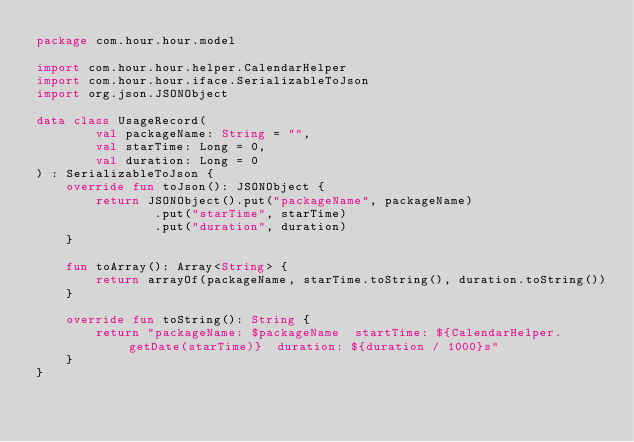Convert code to text. <code><loc_0><loc_0><loc_500><loc_500><_Kotlin_>package com.hour.hour.model

import com.hour.hour.helper.CalendarHelper
import com.hour.hour.iface.SerializableToJson
import org.json.JSONObject

data class UsageRecord(
        val packageName: String = "",
        val starTime: Long = 0,
        val duration: Long = 0
) : SerializableToJson {
    override fun toJson(): JSONObject {
        return JSONObject().put("packageName", packageName)
                .put("starTime", starTime)
                .put("duration", duration)
    }

    fun toArray(): Array<String> {
        return arrayOf(packageName, starTime.toString(), duration.toString())
    }

    override fun toString(): String {
        return "packageName: $packageName  startTime: ${CalendarHelper.getDate(starTime)}  duration: ${duration / 1000}s"
    }
}
</code> 